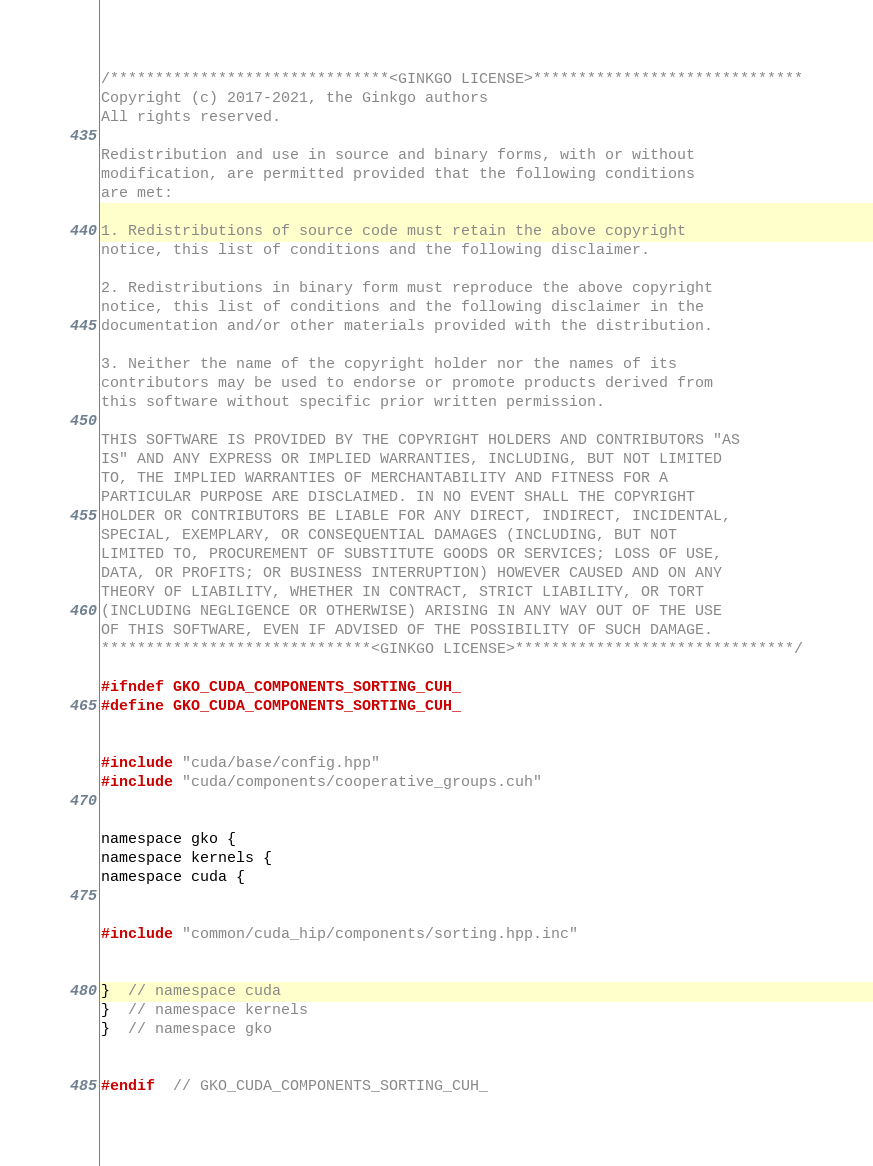Convert code to text. <code><loc_0><loc_0><loc_500><loc_500><_Cuda_>/*******************************<GINKGO LICENSE>******************************
Copyright (c) 2017-2021, the Ginkgo authors
All rights reserved.

Redistribution and use in source and binary forms, with or without
modification, are permitted provided that the following conditions
are met:

1. Redistributions of source code must retain the above copyright
notice, this list of conditions and the following disclaimer.

2. Redistributions in binary form must reproduce the above copyright
notice, this list of conditions and the following disclaimer in the
documentation and/or other materials provided with the distribution.

3. Neither the name of the copyright holder nor the names of its
contributors may be used to endorse or promote products derived from
this software without specific prior written permission.

THIS SOFTWARE IS PROVIDED BY THE COPYRIGHT HOLDERS AND CONTRIBUTORS "AS
IS" AND ANY EXPRESS OR IMPLIED WARRANTIES, INCLUDING, BUT NOT LIMITED
TO, THE IMPLIED WARRANTIES OF MERCHANTABILITY AND FITNESS FOR A
PARTICULAR PURPOSE ARE DISCLAIMED. IN NO EVENT SHALL THE COPYRIGHT
HOLDER OR CONTRIBUTORS BE LIABLE FOR ANY DIRECT, INDIRECT, INCIDENTAL,
SPECIAL, EXEMPLARY, OR CONSEQUENTIAL DAMAGES (INCLUDING, BUT NOT
LIMITED TO, PROCUREMENT OF SUBSTITUTE GOODS OR SERVICES; LOSS OF USE,
DATA, OR PROFITS; OR BUSINESS INTERRUPTION) HOWEVER CAUSED AND ON ANY
THEORY OF LIABILITY, WHETHER IN CONTRACT, STRICT LIABILITY, OR TORT
(INCLUDING NEGLIGENCE OR OTHERWISE) ARISING IN ANY WAY OUT OF THE USE
OF THIS SOFTWARE, EVEN IF ADVISED OF THE POSSIBILITY OF SUCH DAMAGE.
******************************<GINKGO LICENSE>*******************************/

#ifndef GKO_CUDA_COMPONENTS_SORTING_CUH_
#define GKO_CUDA_COMPONENTS_SORTING_CUH_


#include "cuda/base/config.hpp"
#include "cuda/components/cooperative_groups.cuh"


namespace gko {
namespace kernels {
namespace cuda {


#include "common/cuda_hip/components/sorting.hpp.inc"


}  // namespace cuda
}  // namespace kernels
}  // namespace gko


#endif  // GKO_CUDA_COMPONENTS_SORTING_CUH_
</code> 